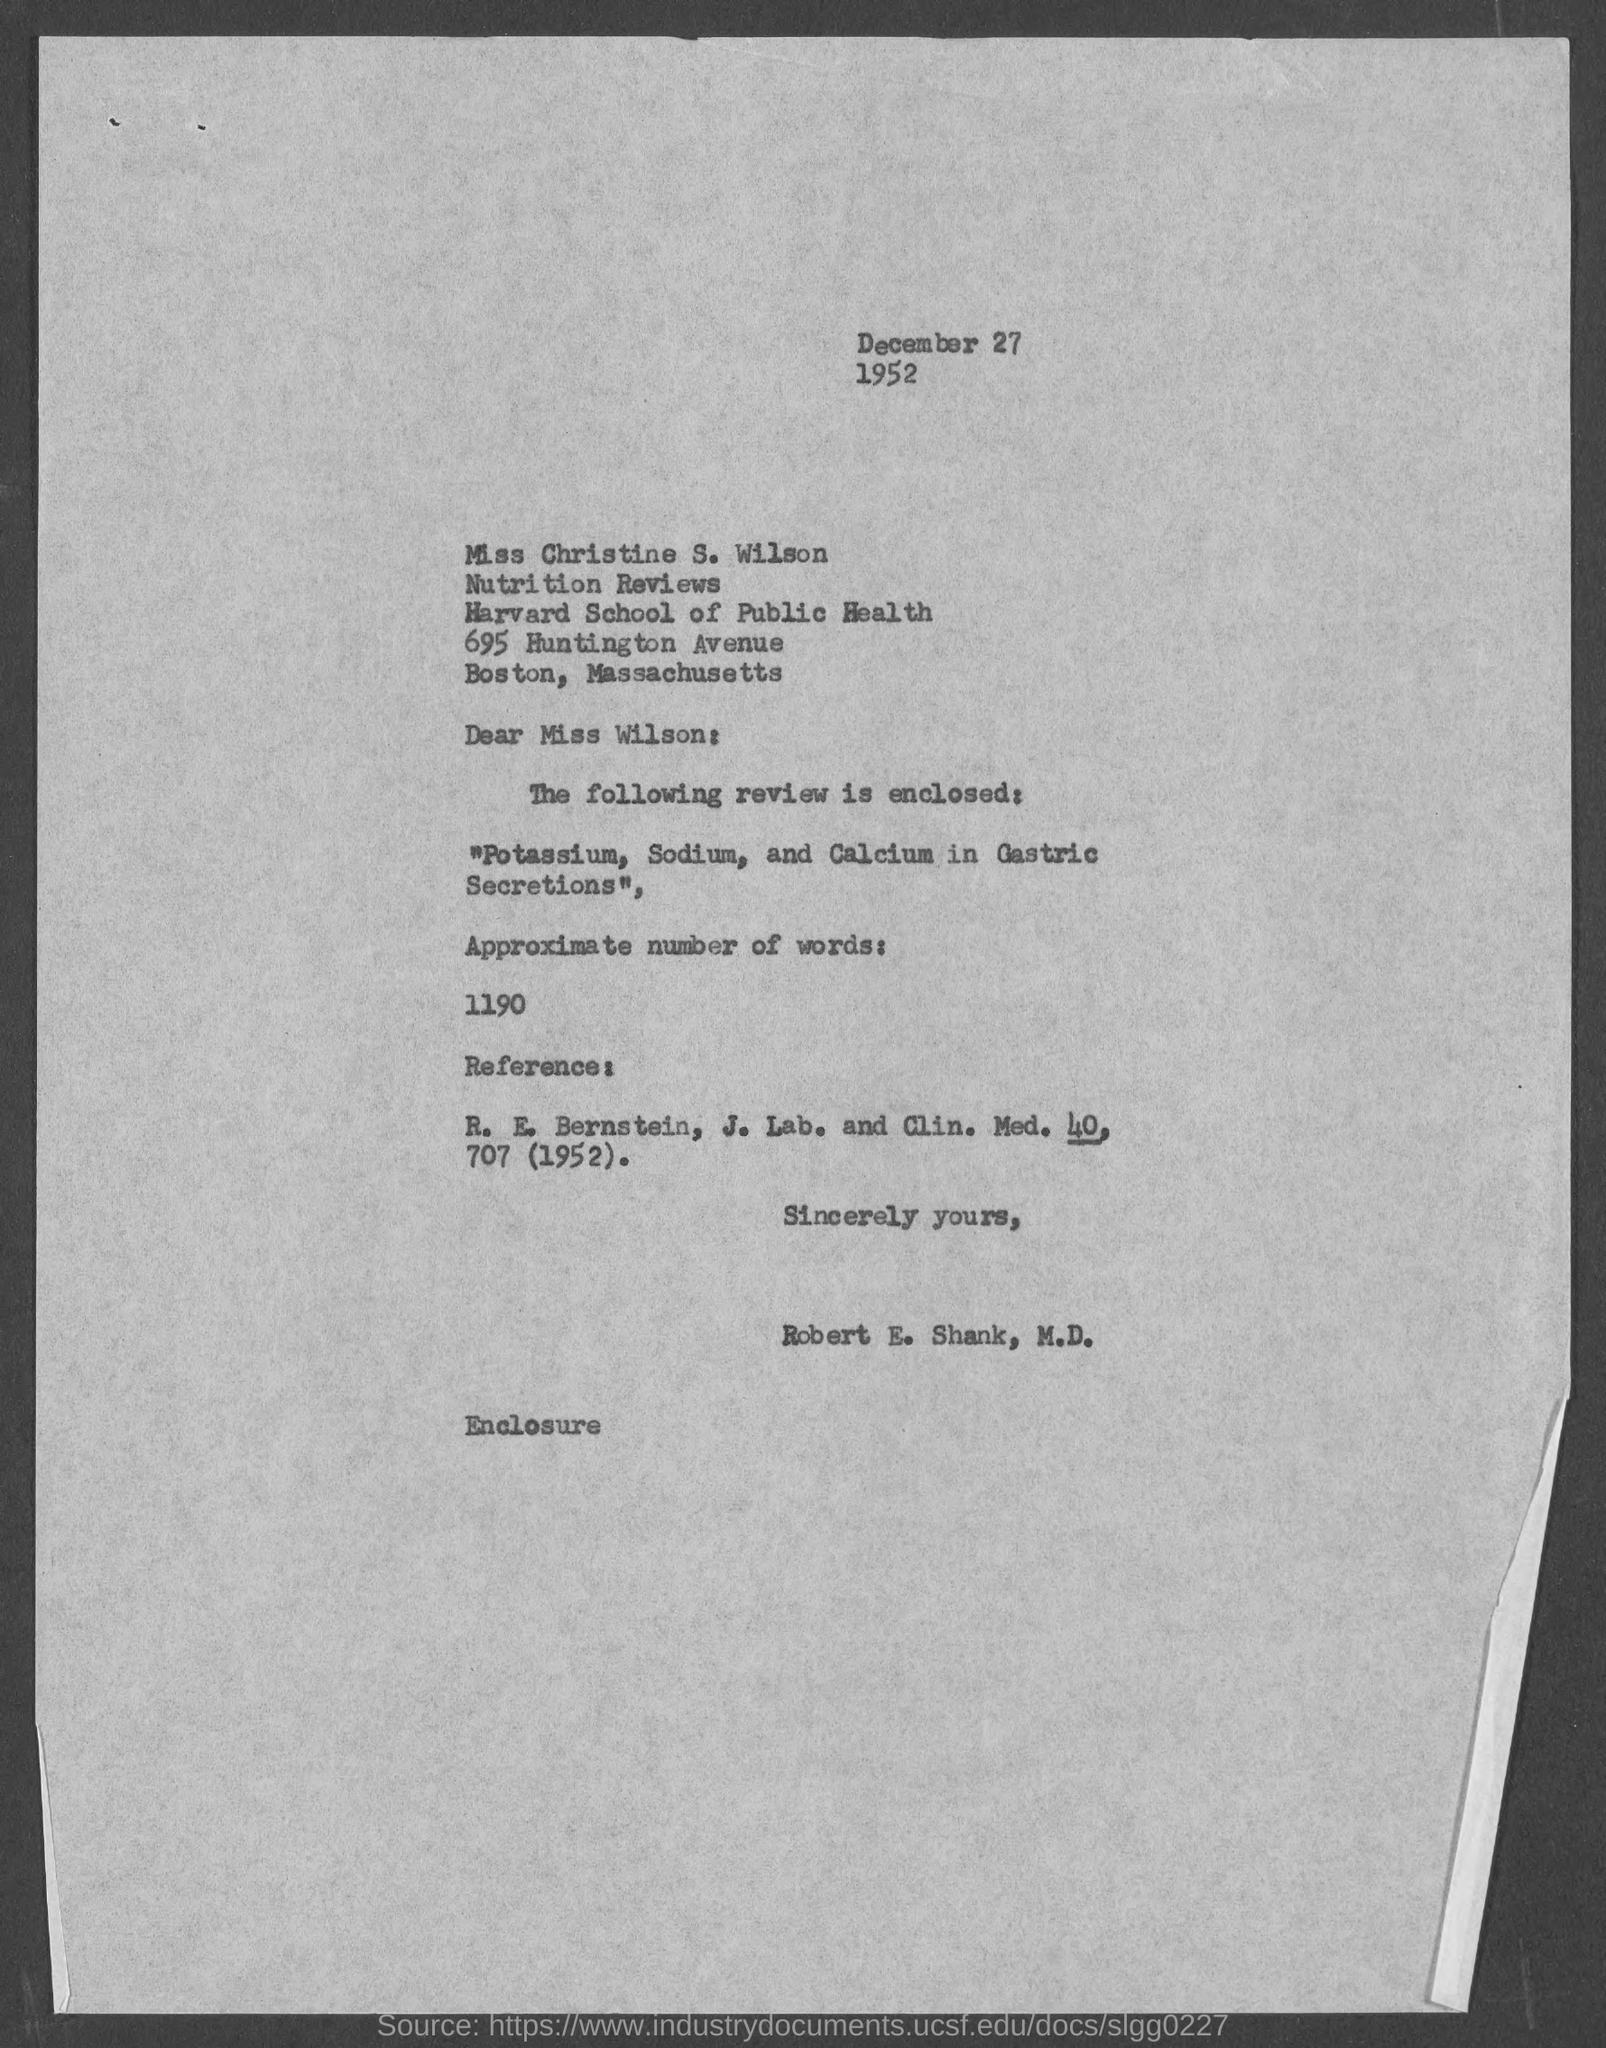Identify some key points in this picture. The memorandum is addressed to Miss Wilson. 